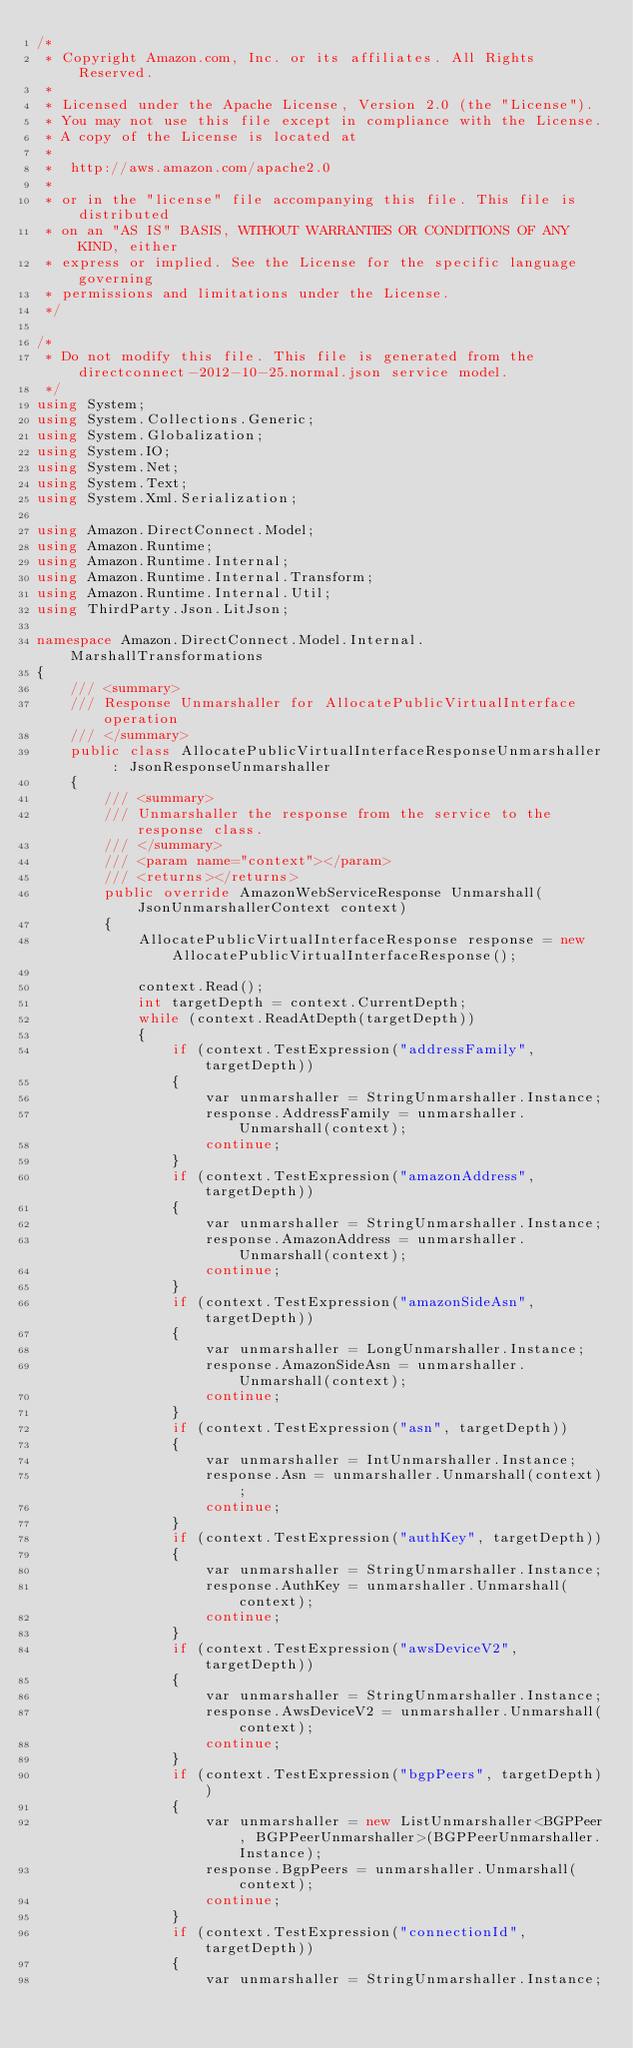Convert code to text. <code><loc_0><loc_0><loc_500><loc_500><_C#_>/*
 * Copyright Amazon.com, Inc. or its affiliates. All Rights Reserved.
 * 
 * Licensed under the Apache License, Version 2.0 (the "License").
 * You may not use this file except in compliance with the License.
 * A copy of the License is located at
 * 
 *  http://aws.amazon.com/apache2.0
 * 
 * or in the "license" file accompanying this file. This file is distributed
 * on an "AS IS" BASIS, WITHOUT WARRANTIES OR CONDITIONS OF ANY KIND, either
 * express or implied. See the License for the specific language governing
 * permissions and limitations under the License.
 */

/*
 * Do not modify this file. This file is generated from the directconnect-2012-10-25.normal.json service model.
 */
using System;
using System.Collections.Generic;
using System.Globalization;
using System.IO;
using System.Net;
using System.Text;
using System.Xml.Serialization;

using Amazon.DirectConnect.Model;
using Amazon.Runtime;
using Amazon.Runtime.Internal;
using Amazon.Runtime.Internal.Transform;
using Amazon.Runtime.Internal.Util;
using ThirdParty.Json.LitJson;

namespace Amazon.DirectConnect.Model.Internal.MarshallTransformations
{
    /// <summary>
    /// Response Unmarshaller for AllocatePublicVirtualInterface operation
    /// </summary>  
    public class AllocatePublicVirtualInterfaceResponseUnmarshaller : JsonResponseUnmarshaller
    {
        /// <summary>
        /// Unmarshaller the response from the service to the response class.
        /// </summary>  
        /// <param name="context"></param>
        /// <returns></returns>
        public override AmazonWebServiceResponse Unmarshall(JsonUnmarshallerContext context)
        {
            AllocatePublicVirtualInterfaceResponse response = new AllocatePublicVirtualInterfaceResponse();

            context.Read();
            int targetDepth = context.CurrentDepth;
            while (context.ReadAtDepth(targetDepth))
            {
                if (context.TestExpression("addressFamily", targetDepth))
                {
                    var unmarshaller = StringUnmarshaller.Instance;
                    response.AddressFamily = unmarshaller.Unmarshall(context);
                    continue;
                }
                if (context.TestExpression("amazonAddress", targetDepth))
                {
                    var unmarshaller = StringUnmarshaller.Instance;
                    response.AmazonAddress = unmarshaller.Unmarshall(context);
                    continue;
                }
                if (context.TestExpression("amazonSideAsn", targetDepth))
                {
                    var unmarshaller = LongUnmarshaller.Instance;
                    response.AmazonSideAsn = unmarshaller.Unmarshall(context);
                    continue;
                }
                if (context.TestExpression("asn", targetDepth))
                {
                    var unmarshaller = IntUnmarshaller.Instance;
                    response.Asn = unmarshaller.Unmarshall(context);
                    continue;
                }
                if (context.TestExpression("authKey", targetDepth))
                {
                    var unmarshaller = StringUnmarshaller.Instance;
                    response.AuthKey = unmarshaller.Unmarshall(context);
                    continue;
                }
                if (context.TestExpression("awsDeviceV2", targetDepth))
                {
                    var unmarshaller = StringUnmarshaller.Instance;
                    response.AwsDeviceV2 = unmarshaller.Unmarshall(context);
                    continue;
                }
                if (context.TestExpression("bgpPeers", targetDepth))
                {
                    var unmarshaller = new ListUnmarshaller<BGPPeer, BGPPeerUnmarshaller>(BGPPeerUnmarshaller.Instance);
                    response.BgpPeers = unmarshaller.Unmarshall(context);
                    continue;
                }
                if (context.TestExpression("connectionId", targetDepth))
                {
                    var unmarshaller = StringUnmarshaller.Instance;</code> 